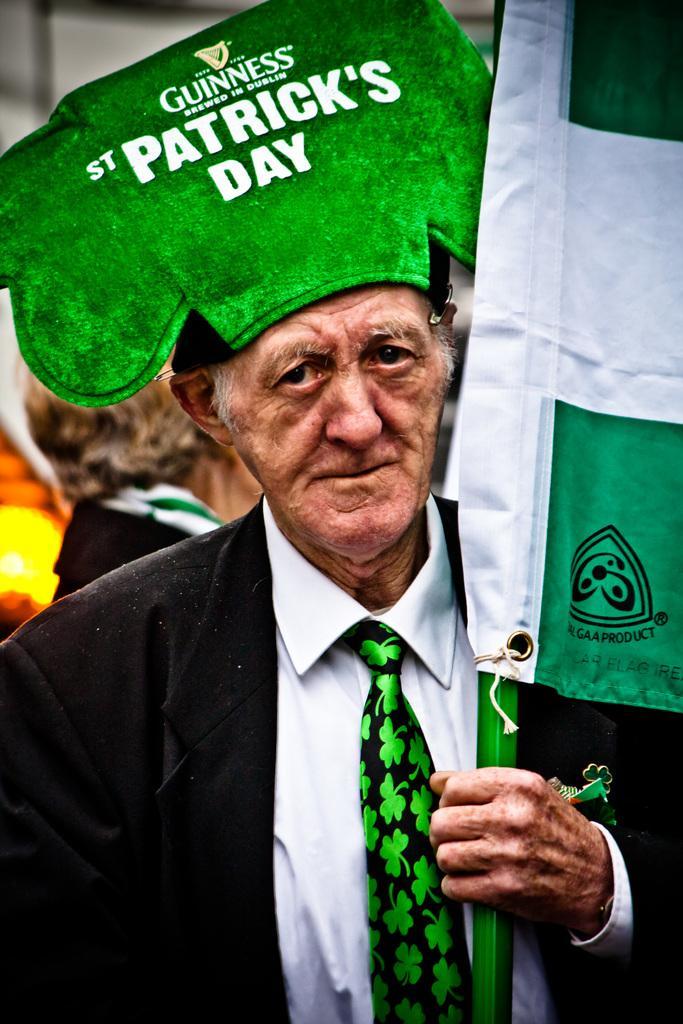Could you give a brief overview of what you see in this image? In this image we can see group of persons. one person is wearing a cap with some text and holding a flag in his hand. 